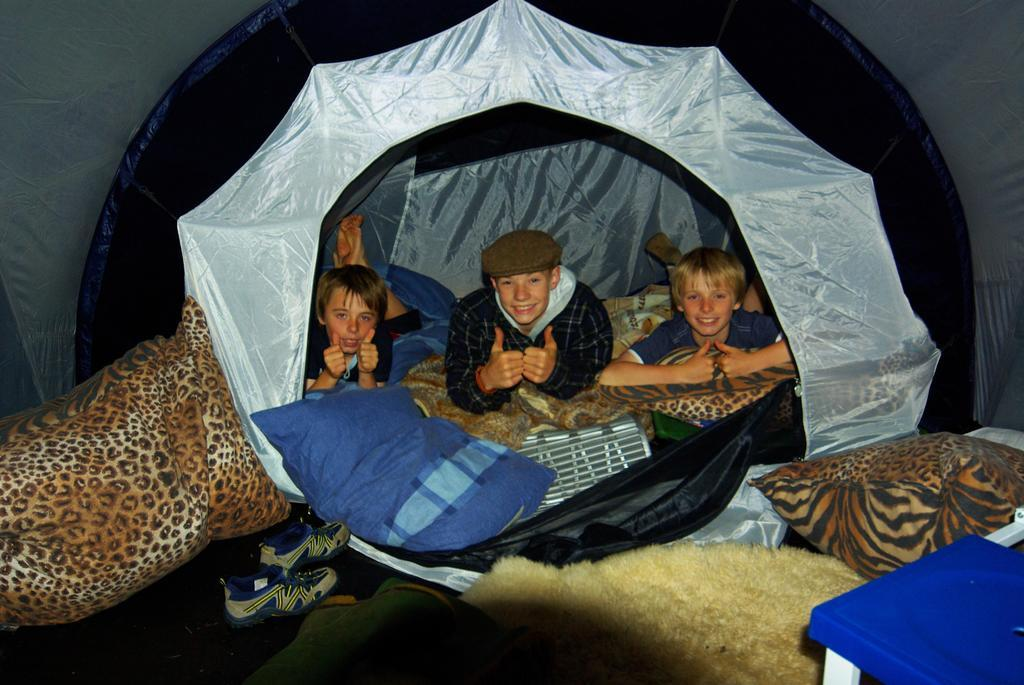How many persons are inside the tent in the image? There are three persons lying in a tent in the image. What are the persons lying on inside the tent? The persons are lying on clothes and pillows. Can you identify any footwear in the image? Yes, there is a pair of shoes in the image. What other items can be seen in the image besides the shoes? There are clothes and pillows in the image. Is there any furniture visible in the image? Yes, there is a table in the image. Where is the cactus located in the image? There is no cactus present in the image. What type of roll is being used by the persons in the image? There is no roll visible in the image; the persons are lying on clothes and pillows. 